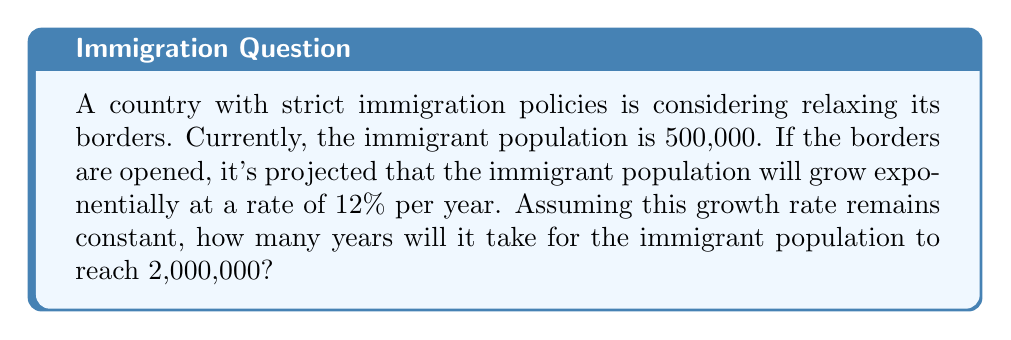Can you answer this question? Let's approach this problem using the exponential growth model:

$A = P(1 + r)^t$

Where:
$A$ = final amount
$P$ = initial principal (starting amount)
$r$ = growth rate (as a decimal)
$t$ = time (in years)

Given:
$P = 500,000$
$r = 0.12$ (12% expressed as a decimal)
$A = 2,000,000$

We need to solve for $t$:

$2,000,000 = 500,000(1 + 0.12)^t$

Divide both sides by 500,000:

$4 = (1.12)^t$

Take the natural log of both sides:

$\ln(4) = t \cdot \ln(1.12)$

Solve for $t$:

$t = \frac{\ln(4)}{\ln(1.12)}$

$t \approx 12.42$ years

Since we can't have a fractional year in this context, we round up to the next whole year.
Answer: 13 years 